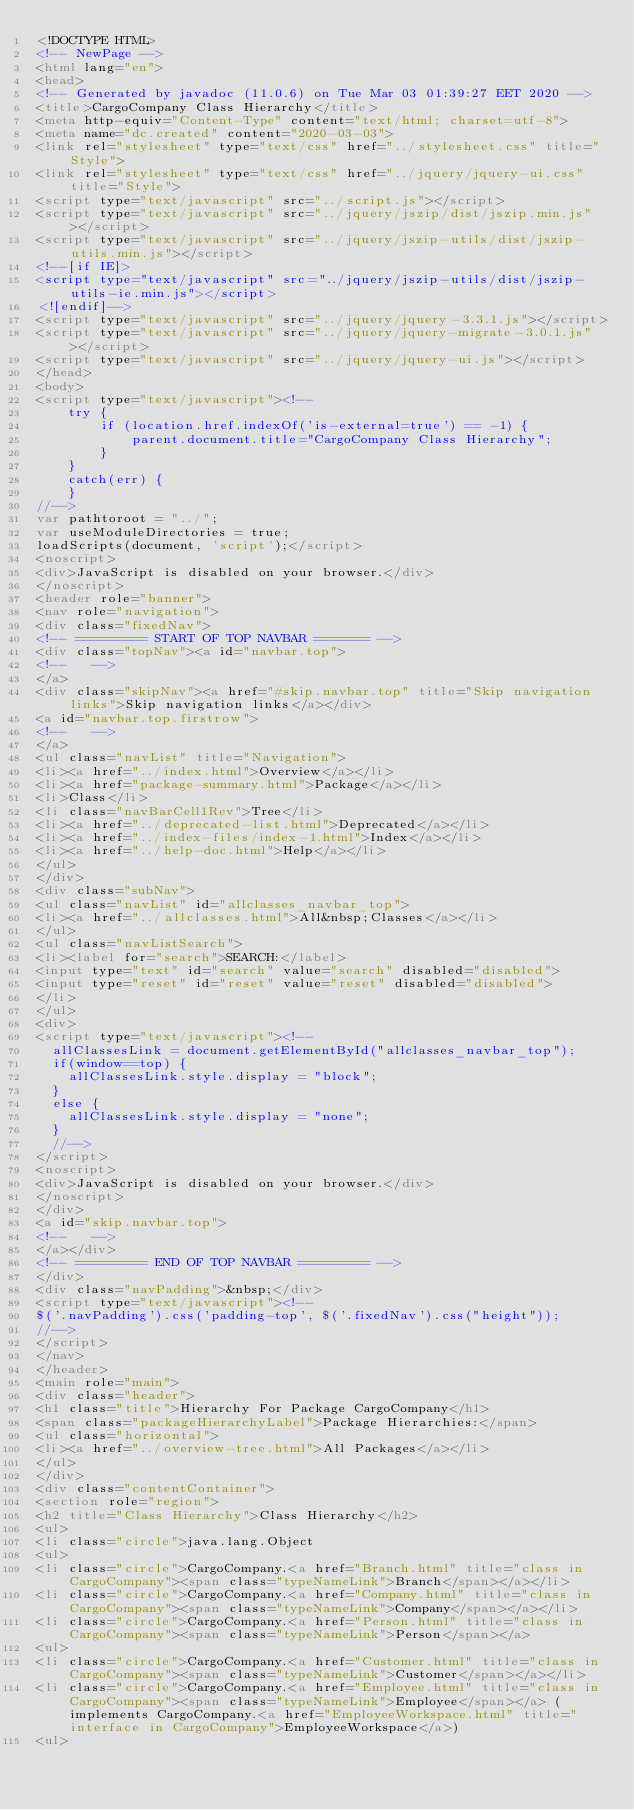<code> <loc_0><loc_0><loc_500><loc_500><_HTML_><!DOCTYPE HTML>
<!-- NewPage -->
<html lang="en">
<head>
<!-- Generated by javadoc (11.0.6) on Tue Mar 03 01:39:27 EET 2020 -->
<title>CargoCompany Class Hierarchy</title>
<meta http-equiv="Content-Type" content="text/html; charset=utf-8">
<meta name="dc.created" content="2020-03-03">
<link rel="stylesheet" type="text/css" href="../stylesheet.css" title="Style">
<link rel="stylesheet" type="text/css" href="../jquery/jquery-ui.css" title="Style">
<script type="text/javascript" src="../script.js"></script>
<script type="text/javascript" src="../jquery/jszip/dist/jszip.min.js"></script>
<script type="text/javascript" src="../jquery/jszip-utils/dist/jszip-utils.min.js"></script>
<!--[if IE]>
<script type="text/javascript" src="../jquery/jszip-utils/dist/jszip-utils-ie.min.js"></script>
<![endif]-->
<script type="text/javascript" src="../jquery/jquery-3.3.1.js"></script>
<script type="text/javascript" src="../jquery/jquery-migrate-3.0.1.js"></script>
<script type="text/javascript" src="../jquery/jquery-ui.js"></script>
</head>
<body>
<script type="text/javascript"><!--
    try {
        if (location.href.indexOf('is-external=true') == -1) {
            parent.document.title="CargoCompany Class Hierarchy";
        }
    }
    catch(err) {
    }
//-->
var pathtoroot = "../";
var useModuleDirectories = true;
loadScripts(document, 'script');</script>
<noscript>
<div>JavaScript is disabled on your browser.</div>
</noscript>
<header role="banner">
<nav role="navigation">
<div class="fixedNav">
<!-- ========= START OF TOP NAVBAR ======= -->
<div class="topNav"><a id="navbar.top">
<!--   -->
</a>
<div class="skipNav"><a href="#skip.navbar.top" title="Skip navigation links">Skip navigation links</a></div>
<a id="navbar.top.firstrow">
<!--   -->
</a>
<ul class="navList" title="Navigation">
<li><a href="../index.html">Overview</a></li>
<li><a href="package-summary.html">Package</a></li>
<li>Class</li>
<li class="navBarCell1Rev">Tree</li>
<li><a href="../deprecated-list.html">Deprecated</a></li>
<li><a href="../index-files/index-1.html">Index</a></li>
<li><a href="../help-doc.html">Help</a></li>
</ul>
</div>
<div class="subNav">
<ul class="navList" id="allclasses_navbar_top">
<li><a href="../allclasses.html">All&nbsp;Classes</a></li>
</ul>
<ul class="navListSearch">
<li><label for="search">SEARCH:</label>
<input type="text" id="search" value="search" disabled="disabled">
<input type="reset" id="reset" value="reset" disabled="disabled">
</li>
</ul>
<div>
<script type="text/javascript"><!--
  allClassesLink = document.getElementById("allclasses_navbar_top");
  if(window==top) {
    allClassesLink.style.display = "block";
  }
  else {
    allClassesLink.style.display = "none";
  }
  //-->
</script>
<noscript>
<div>JavaScript is disabled on your browser.</div>
</noscript>
</div>
<a id="skip.navbar.top">
<!--   -->
</a></div>
<!-- ========= END OF TOP NAVBAR ========= -->
</div>
<div class="navPadding">&nbsp;</div>
<script type="text/javascript"><!--
$('.navPadding').css('padding-top', $('.fixedNav').css("height"));
//-->
</script>
</nav>
</header>
<main role="main">
<div class="header">
<h1 class="title">Hierarchy For Package CargoCompany</h1>
<span class="packageHierarchyLabel">Package Hierarchies:</span>
<ul class="horizontal">
<li><a href="../overview-tree.html">All Packages</a></li>
</ul>
</div>
<div class="contentContainer">
<section role="region">
<h2 title="Class Hierarchy">Class Hierarchy</h2>
<ul>
<li class="circle">java.lang.Object
<ul>
<li class="circle">CargoCompany.<a href="Branch.html" title="class in CargoCompany"><span class="typeNameLink">Branch</span></a></li>
<li class="circle">CargoCompany.<a href="Company.html" title="class in CargoCompany"><span class="typeNameLink">Company</span></a></li>
<li class="circle">CargoCompany.<a href="Person.html" title="class in CargoCompany"><span class="typeNameLink">Person</span></a>
<ul>
<li class="circle">CargoCompany.<a href="Customer.html" title="class in CargoCompany"><span class="typeNameLink">Customer</span></a></li>
<li class="circle">CargoCompany.<a href="Employee.html" title="class in CargoCompany"><span class="typeNameLink">Employee</span></a> (implements CargoCompany.<a href="EmployeeWorkspace.html" title="interface in CargoCompany">EmployeeWorkspace</a>)
<ul></code> 